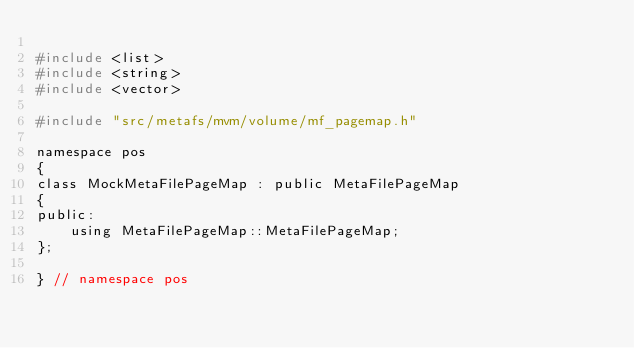<code> <loc_0><loc_0><loc_500><loc_500><_C_>
#include <list>
#include <string>
#include <vector>

#include "src/metafs/mvm/volume/mf_pagemap.h"

namespace pos
{
class MockMetaFilePageMap : public MetaFilePageMap
{
public:
    using MetaFilePageMap::MetaFilePageMap;
};

} // namespace pos
</code> 